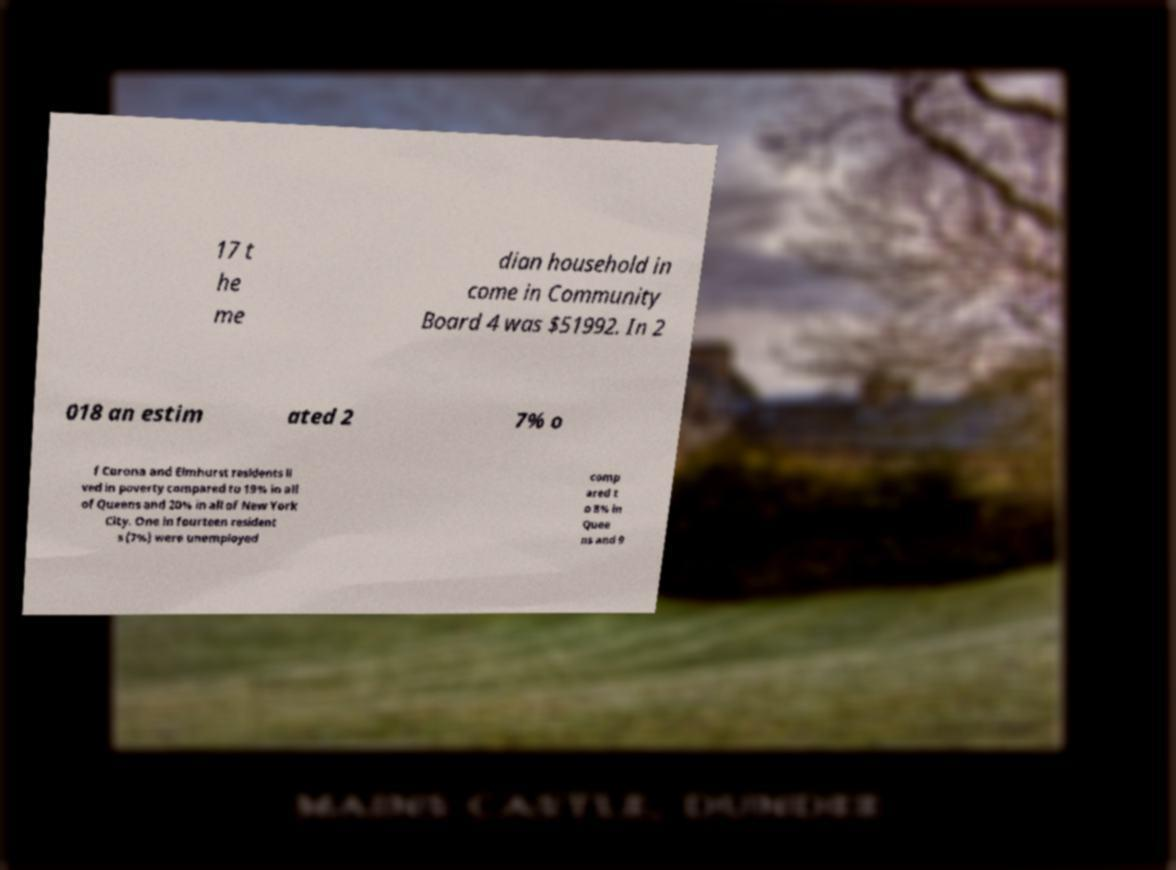Can you accurately transcribe the text from the provided image for me? 17 t he me dian household in come in Community Board 4 was $51992. In 2 018 an estim ated 2 7% o f Corona and Elmhurst residents li ved in poverty compared to 19% in all of Queens and 20% in all of New York City. One in fourteen resident s (7%) were unemployed comp ared t o 8% in Quee ns and 9 